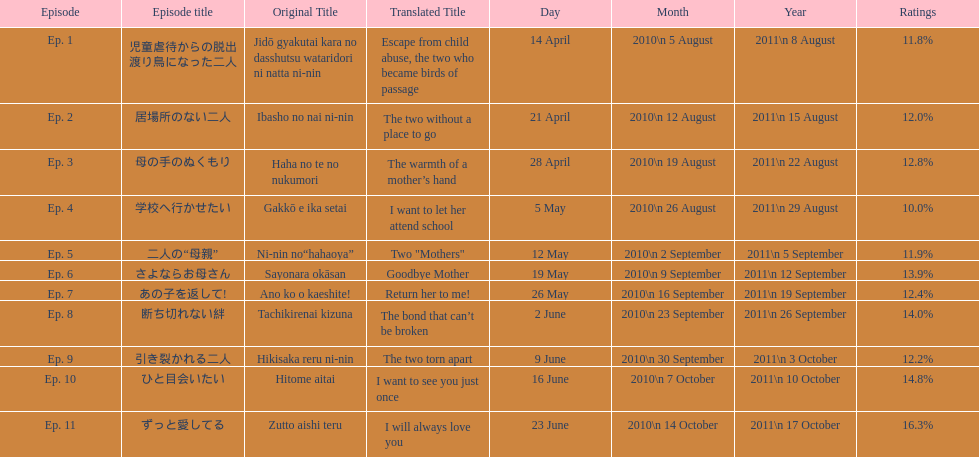How many episode are not over 14%? 8. 